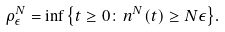<formula> <loc_0><loc_0><loc_500><loc_500>\rho _ { \epsilon } ^ { N } = \inf { \left \{ t \geq 0 \colon n ^ { N } ( t ) \geq N \epsilon \right \} } .</formula> 